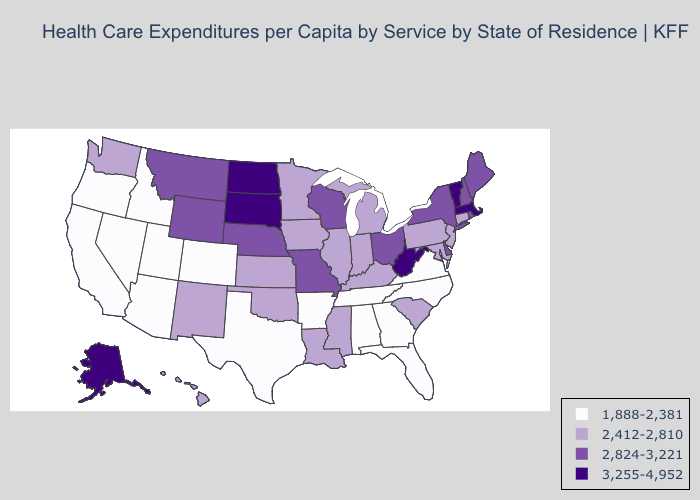What is the value of Florida?
Give a very brief answer. 1,888-2,381. What is the value of Kansas?
Give a very brief answer. 2,412-2,810. Does Washington have the same value as Oregon?
Be succinct. No. Does Pennsylvania have the lowest value in the USA?
Quick response, please. No. Name the states that have a value in the range 3,255-4,952?
Keep it brief. Alaska, Massachusetts, North Dakota, South Dakota, Vermont, West Virginia. What is the highest value in the MidWest ?
Concise answer only. 3,255-4,952. What is the value of Arkansas?
Short answer required. 1,888-2,381. Name the states that have a value in the range 1,888-2,381?
Write a very short answer. Alabama, Arizona, Arkansas, California, Colorado, Florida, Georgia, Idaho, Nevada, North Carolina, Oregon, Tennessee, Texas, Utah, Virginia. What is the value of Wisconsin?
Write a very short answer. 2,824-3,221. What is the value of Kentucky?
Give a very brief answer. 2,412-2,810. What is the value of Illinois?
Be succinct. 2,412-2,810. Name the states that have a value in the range 2,824-3,221?
Answer briefly. Delaware, Maine, Missouri, Montana, Nebraska, New Hampshire, New York, Ohio, Rhode Island, Wisconsin, Wyoming. How many symbols are there in the legend?
Short answer required. 4. Does the map have missing data?
Keep it brief. No. What is the lowest value in the West?
Keep it brief. 1,888-2,381. 